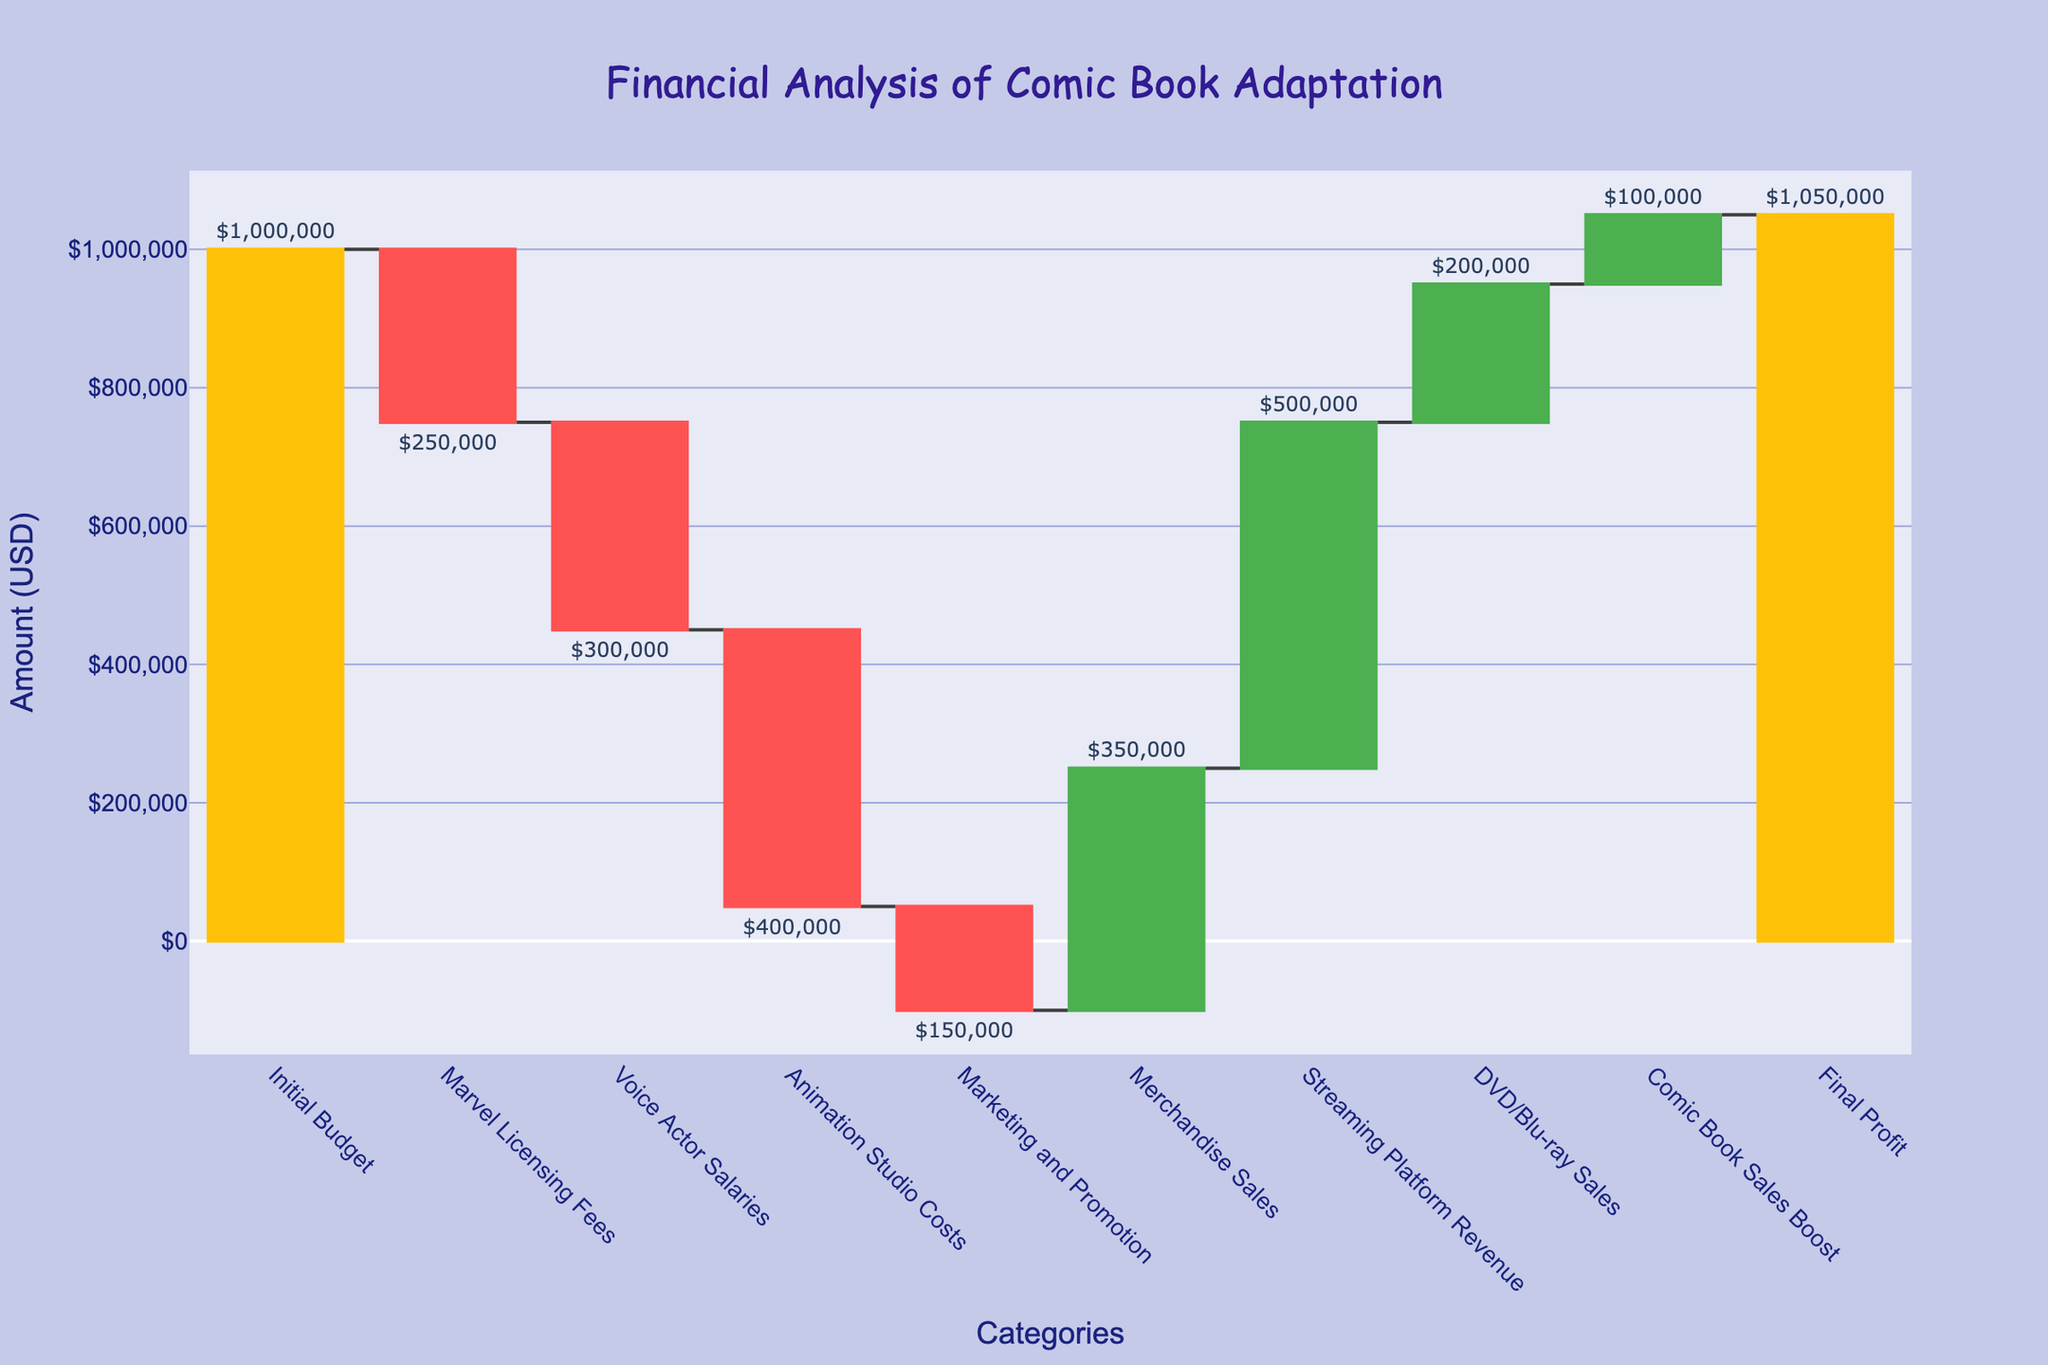What is the title of the chart? The title of the chart is usually displayed at the top of the figure and provides a concise description of the content. In this case, the title is "Financial Analysis of Comic Book Adaptation".
Answer: Financial Analysis of Comic Book Adaptation How many categories are presented in the chart? To find the number of categories, count the distinct labels on the x-axis of the waterfall chart: Initial Budget, Marvel Licensing Fees, Voice Actor Salaries, Animation Studio Costs, Marketing and Promotion, Merchandise Sales, Streaming Platform Revenue, DVD/Blu-ray Sales, Comic Book Sales Boost, and Final Profit.
Answer: 10 What are the total animation studio costs? Animation Studio Costs are explicitly listed as one of the categories on the x-axis. The corresponding bar shows the expense value.
Answer: $400,000 Which category shows the highest expense? To determine the highest expense, look for the bar representing the most substantial downward movement (negative value) among the expenses. Here, the Animation Studio Costs represent the highest expense at $400,000.
Answer: Animation Studio Costs How much profit does the streaming platform revenue contribute? Locate the Streaming Platform Revenue bar on the x-axis and read the corresponding value. The Streaming Platform Revenue contributes $500,000 as an increase.
Answer: $500,000 What is the amount added by merchandising sales? Find the Merchandise Sales category on the x-axis and note the bar's height representing the contribution. Merchandise Sales add $350,000 as an increase.
Answer: $350,000 What is the final profit? The final profit is shown at the end of the waterfall chart which is labeled as Final Profit.
Answer: $1,050,000 Calculate the total expenses. Sum the values of all expense categories, including Marvel Licensing Fees, Voice Actor Salaries, Animation Studio Costs, and Marketing and Promotion: $250,000 + $300,000 + $400,000 + $150,000 = $1,100,000.
Answer: $1,100,000 Compare the initial budget and the final profit. Which one is higher? The initial budget is $1,000,000, while the final profit is $1,050,000. By comparing these two values, we see the final profit is higher.
Answer: Final Profit is higher What is the net income generated after all expenses? The net income is calculated by summing all incomes and subtracting all expenses from the initial budget: $1,000,000 (Initial Budget) - $1,100,000 (Total Expenses) + $1,150,000 (Total Revenues) = $1,050,000.
Answer: $1,050,000 